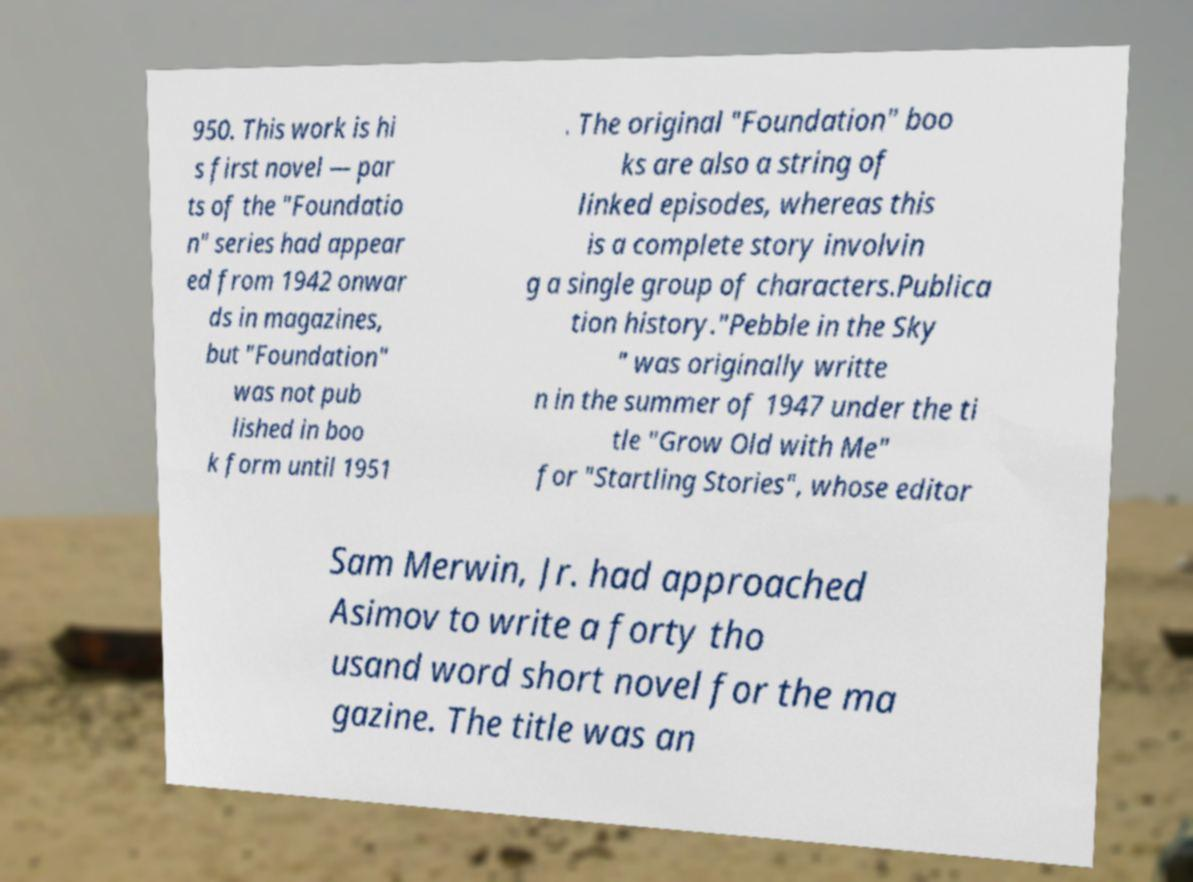Could you assist in decoding the text presented in this image and type it out clearly? 950. This work is hi s first novel — par ts of the "Foundatio n" series had appear ed from 1942 onwar ds in magazines, but "Foundation" was not pub lished in boo k form until 1951 . The original "Foundation" boo ks are also a string of linked episodes, whereas this is a complete story involvin g a single group of characters.Publica tion history."Pebble in the Sky " was originally writte n in the summer of 1947 under the ti tle "Grow Old with Me" for "Startling Stories", whose editor Sam Merwin, Jr. had approached Asimov to write a forty tho usand word short novel for the ma gazine. The title was an 